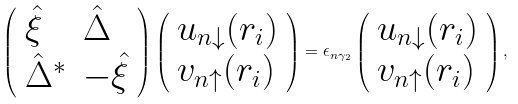<formula> <loc_0><loc_0><loc_500><loc_500>\left ( \begin{array} { l l } \hat { \xi } & \hat { \Delta } \\ \hat { \Delta } ^ { \ast } & - \hat { \xi } \end{array} \right ) \left ( \begin{array} { l l } u _ { n \downarrow } ( r _ { i } ) \\ v _ { n \uparrow } ( r _ { i } ) \end{array} \right ) = \epsilon _ { n \gamma _ { 2 } } \left ( \begin{array} { l l } u _ { n \downarrow } ( r _ { i } ) \\ v _ { n \uparrow } ( r _ { i } ) \end{array} \right ) ,</formula> 